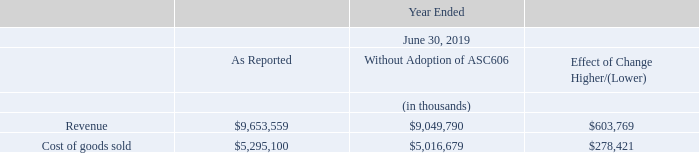Upon adoption, the Company recorded a cumulative effect adjustment of $139.4 million, net of tax adjustment of $21.0 million, which increased the June 25, 2018 opening retained earnings balance on the Condensed Consolidated Balance Sheet, primarily as a result of changes in the timing of recognition of system sales. Under ASC 606, the Company recognizes revenue from sales of systems when the Company determines that control has passed to the customer which is generally (1) for products that have been demonstrated to meet product specifications prior to shipment upon shipment or delivery; (2) for products that have not been demonstrated to meet product specifications prior to shipment, revenue is recognized upon completion of installation and receipt of customer acceptance; (3) for transactions where legal title does not pass upon shipment or delivery and the Company does not have a right to payment, revenue is recognized when legal title passes to the customer and the Company has a right to payment, which is generally at customer acceptance.
The impact of adoption of ASC 606 on the Company’s Consolidated Statement of Operations and Consolidated Balance Sheet was as follows:
Except as disclosed above, the adoption of ASC 606 did not have a significant impact on the Company’s Consolidated Statement of Operations for the year ended June 30, 2019.
In January 2016, the FASB released ASU 2016-01, “Financial Instruments – Overall – Recognition and Measurement of Financial Assets and Financial Liabilities.” The FASB issued a subsequent amendment to the initial guidance in February 2018 within ASU 2018-03. These amendments change the accounting for and financial statement presentation of equity investments, other than those accounted for under the equity method of accounting or those that result in consolidation of the investee. The amendments provide clarity on the measurement methodology to be used for the required disclosure of fair value of financial instruments measured at amortized cost on the balance sheet and clarifies that an entity should evaluate the need for a valuation allowance on deferred tax assets related to available-for-sale securities in combination with the entity’s other deferred tax assets, among other changes. The Company’s adoption of this standard in the first quarter of fiscal year 2019 did not have a material impact on its Consolidated Financial Statements.
In August 2016, the FASB released ASU 2016-15, “Statement of Cash Flows – Classification of Certain Cash Receipts and Cash Payments.” The amendment provides and clarifies guidance on the classification of certain cash receipts and cash payments in the statement of cash flows to eliminate diversity in practice. The Company adopted the standard update in the first quarter of fiscal year 2019, using a retrospective transition method. The Company’s adoption of this standard did not have a material impact on its Consolidated Financial Statements.
In October 2016, the FASB released ASU 2016-16, “Income Tax – Intra-Entity Transfers of Assets Other than Inventory.” This standard update improves the accounting for the income tax consequences of intra-entity transfers of assets other than inventory. The Company adopted this standard in the first quarter of fiscal year 2019 using a modified-retrospective approach through a cumulative-effect adjustment directly to retained earnings. The Company’s adoption of this standard resulted in a $0.4 million decrease to retained earnings and a corresponding $0.4 million offset to other assets on its Consolidated Financial Statements.
In November 2016, the FASB released ASU 2016-18, “Statement of Cash Flows – Restricted Cash.” This standard update requires that restricted cash and restricted cash equivalents be included in cash and cash equivalents when reconciling the beginning-of-period and end-of-period total amounts shown in the statement of cash flows. The Company adopted this standard in the first quarter of fiscal year 2019, using a retrospective transition method to each period presented. The adoption of this standard did not have a material impact on its Consolidated Financial Statements.
In February 2018, the FASB released ASU 2018-02, “Reclassification of Certain Tax Effects from Accumulated Other Comprehensive Income.” This standard update addresses a specific consequence of the Tax Cuts and Jobs Act (“U.S. Tax Reform”) and allows a reclassification from accumulated other comprehensive income to retained earnings for the stranded tax effects resulting from U.S. tax reform. Consequently, the update eliminates the stranded tax effects that were created as a result of the historical U.S. federal corporate income tax rate to the newly enacted U.S. federal corporate income tax rate. The Company adopted this standard in the first quarter of fiscal year 2019 using a modified-retrospective approach through a cumulative-effect adjustment directly to retained earnings. The adoption of this standard resulted in a $2.2 million increase to retained earnings, with a corresponding $2.2 million decrease to other comprehensive income.
In August 2018, the Securities and Exchange Commission (“SEC”) adopted amendments to eliminate, integrate, update or modify certain of its disclosure requirements. The amendments are part of the SEC’s efforts to improve disclosure effectiveness and were focused on eliminating disclosure requirements that have become redundant, duplicative, overlapping, outdated, or superseded. The Company adopted these amendments in the first quarter of fiscal Year 2019. The adoption of these amendments resulted in minor changes within its Consolidated Financial Statements.
How did the Company adopt the ASU 2018-02, “Reclassification of Certain Tax Effects from Accumulated Other Comprehensive Income" standard? Using a modified-retrospective approach through a cumulative-effect adjustment directly to retained earnings. What did the adoption of the standard result in? A $2.2 million increase to retained earnings, with a corresponding $2.2 million decrease to other comprehensive income. What did the adoption of the amendments result in? Minor changes within its consolidated financial statements. What is the gross profit as reported in 2019?
Answer scale should be: thousand. 9,653,559-5,295,100
Answer: 4358459. What is the gross profit ratio as reported in 2019?
Answer scale should be: percent. (9,653,559-5,295,100)/9,653,559
Answer: 45.15. What is the percentage change in the revenue after the adoption of ASC606?
Answer scale should be: percent. (9,653,559-9,049,790)/9,049,790
Answer: 6.67. 